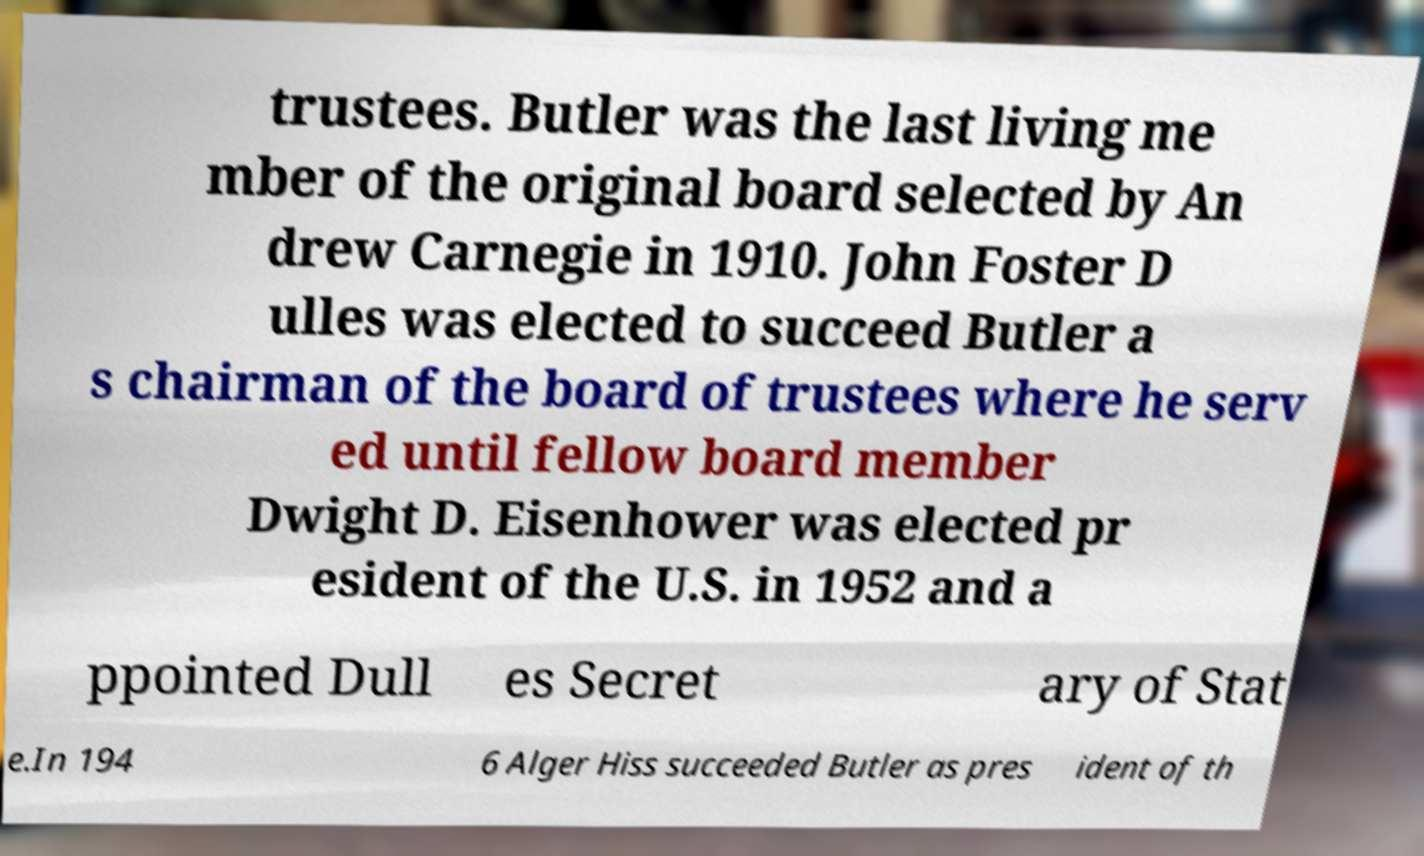I need the written content from this picture converted into text. Can you do that? trustees. Butler was the last living me mber of the original board selected by An drew Carnegie in 1910. John Foster D ulles was elected to succeed Butler a s chairman of the board of trustees where he serv ed until fellow board member Dwight D. Eisenhower was elected pr esident of the U.S. in 1952 and a ppointed Dull es Secret ary of Stat e.In 194 6 Alger Hiss succeeded Butler as pres ident of th 